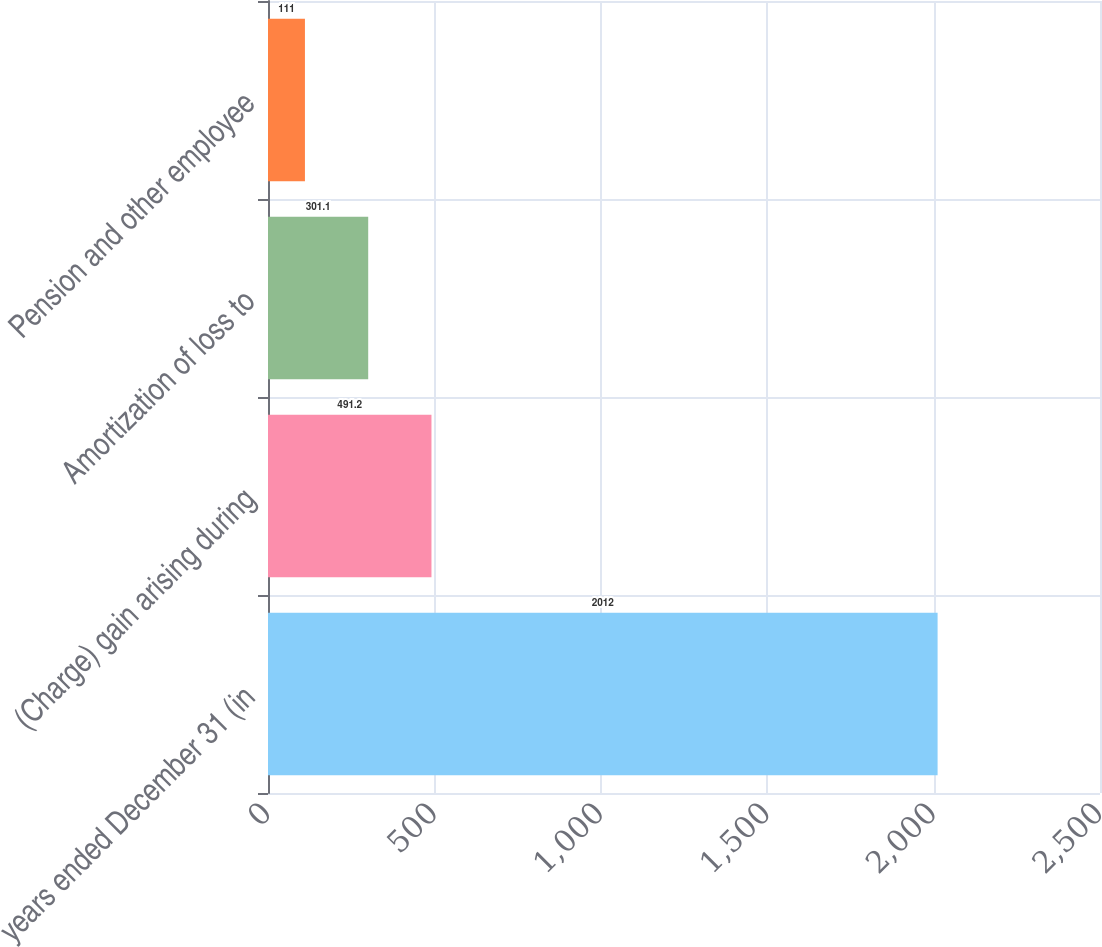<chart> <loc_0><loc_0><loc_500><loc_500><bar_chart><fcel>years ended December 31 (in<fcel>(Charge) gain arising during<fcel>Amortization of loss to<fcel>Pension and other employee<nl><fcel>2012<fcel>491.2<fcel>301.1<fcel>111<nl></chart> 